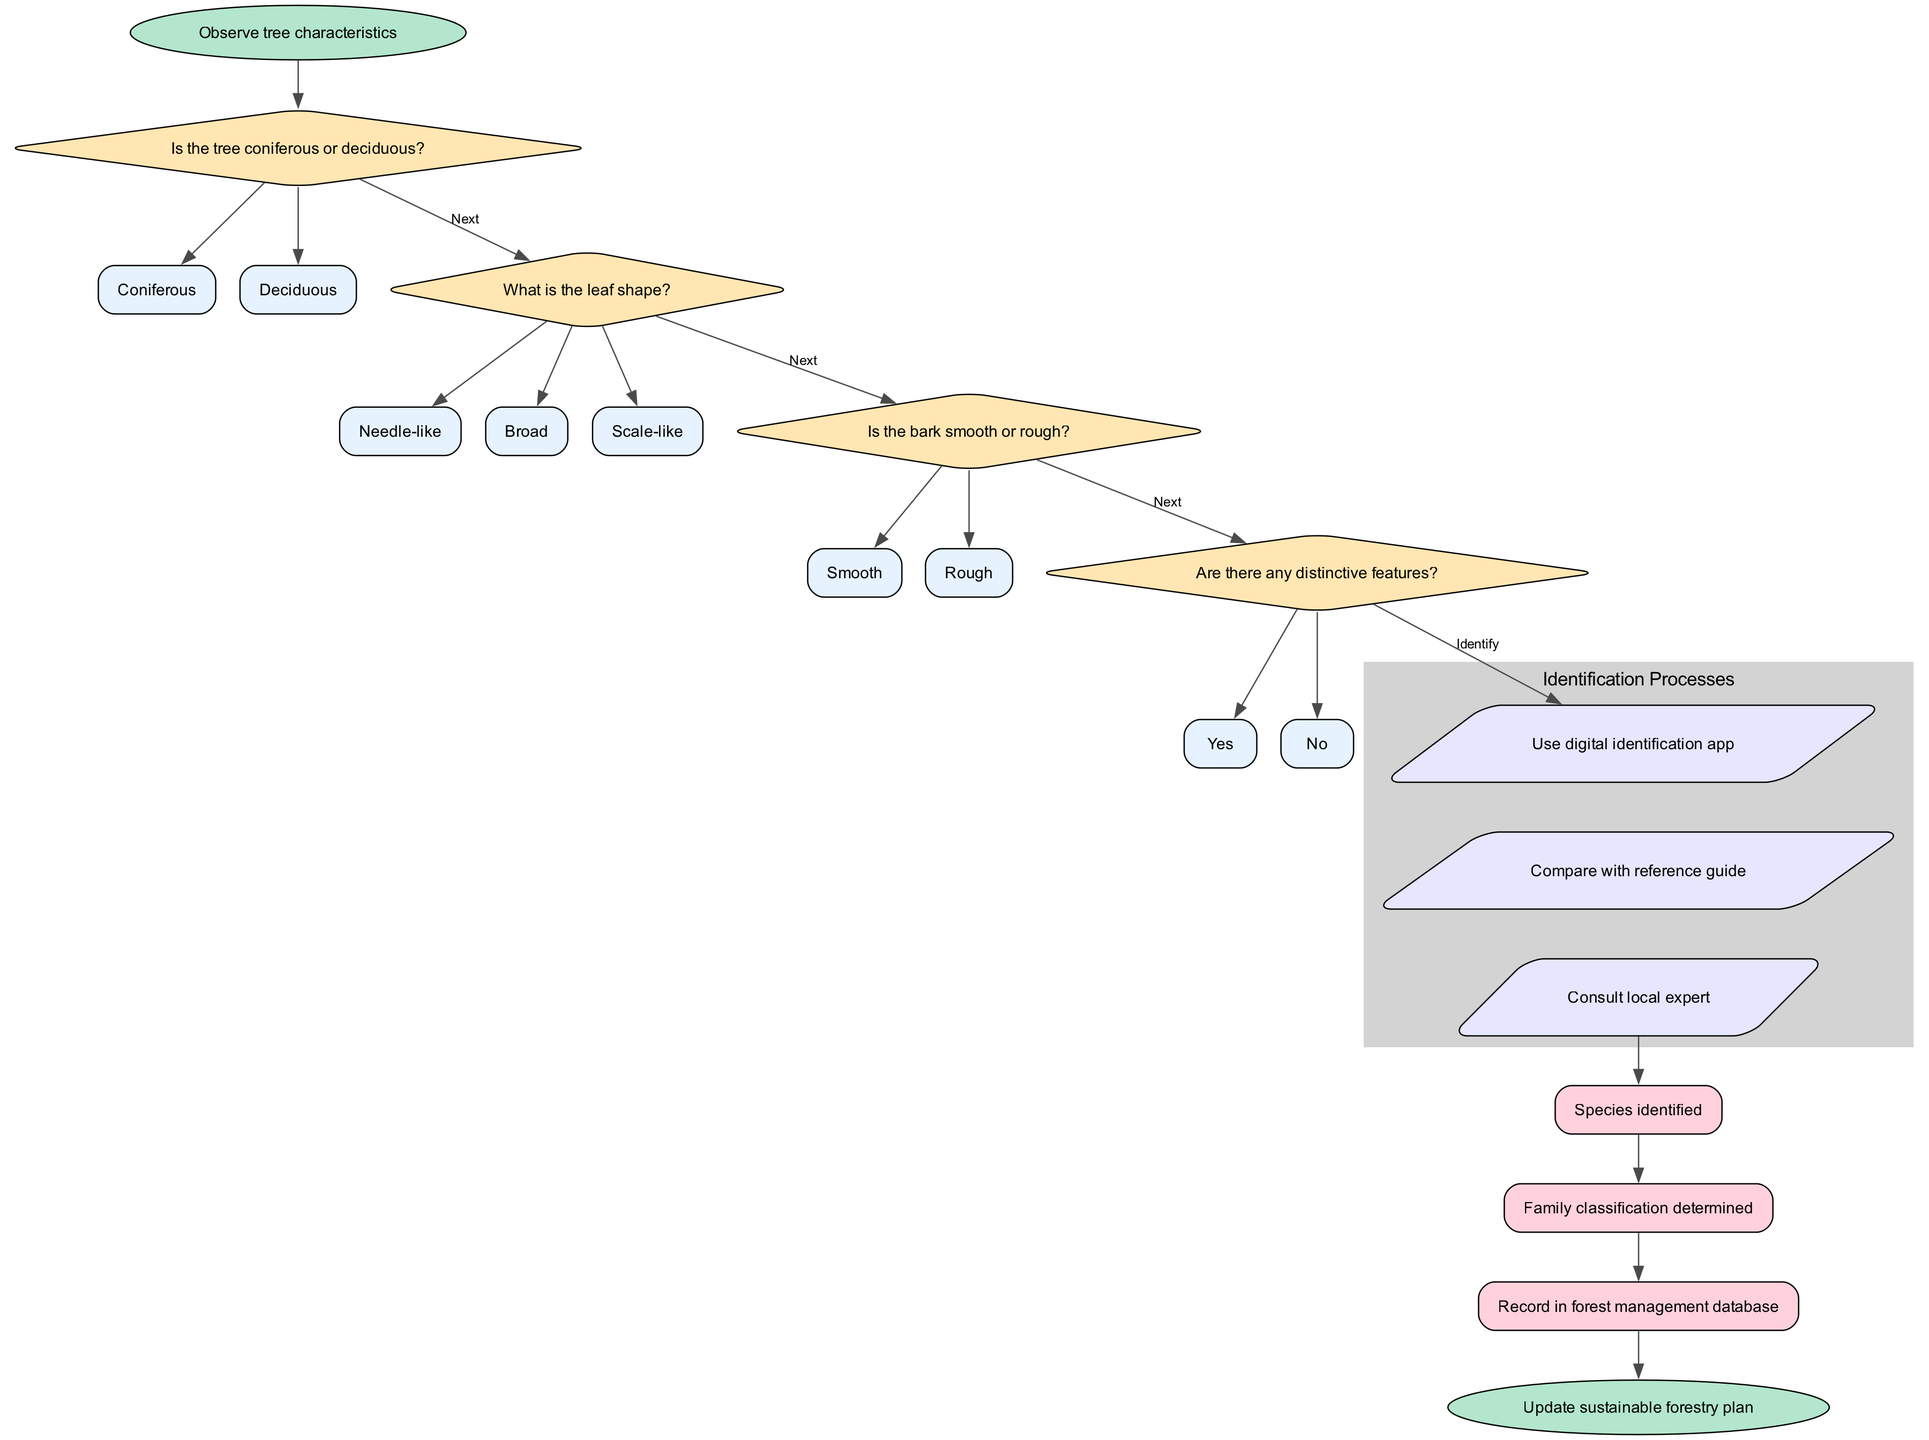What is the first action in the flowchart? The flowchart starts with the action "Observe tree characteristics" which is indicated in the start node of the diagram.
Answer: Observe tree characteristics What type of decision is made after observing tree characteristics? The next decision made is to determine whether the tree is "Coniferous" or "Deciduous," as indicated by the first decision node.
Answer: Is the tree coniferous or deciduous? How many options are there for the second decision about leaf shape? The second decision presents three options: "Needle-like", "Broad", and "Scale-like." Therefore, there are three options for this decision.
Answer: Three Which process is the first mentioned after a decision? The first process mentioned in the diagram after making decisions is "Use digital identification app." This is the initial step indicated in the process nodes.
Answer: Use digital identification app What is the last output indicated in the flowchart? The final output depicted in the flowchart is "Record in forest management database," which represents the last outcome of the identification process.
Answer: Record in forest management database What is the total number of decision nodes in the flowchart? The flowchart contains four decision nodes, each representing a different question regarding the tree identification process.
Answer: Four After the last decision, which process follows? After the last decision regarding distinctive features, the next process that follows is "Use digital identification app," as it connects the decision to the identification process.
Answer: Use digital identification app What is the color of the start node in the diagram? The start node, which represents the initial action in the flowchart, is colored "#B3E6CC" as defined in the diagram attributes.
Answer: #B3E6CC What does the final node in the flowchart indicate? The final node in the flowchart indicates the action "Update sustainable forestry plan," marking the end of the tree species identification process.
Answer: Update sustainable forestry plan 